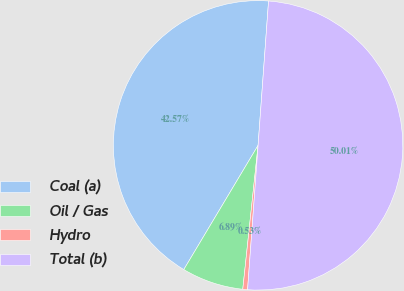Convert chart. <chart><loc_0><loc_0><loc_500><loc_500><pie_chart><fcel>Coal (a)<fcel>Oil / Gas<fcel>Hydro<fcel>Total (b)<nl><fcel>42.57%<fcel>6.89%<fcel>0.53%<fcel>50.0%<nl></chart> 